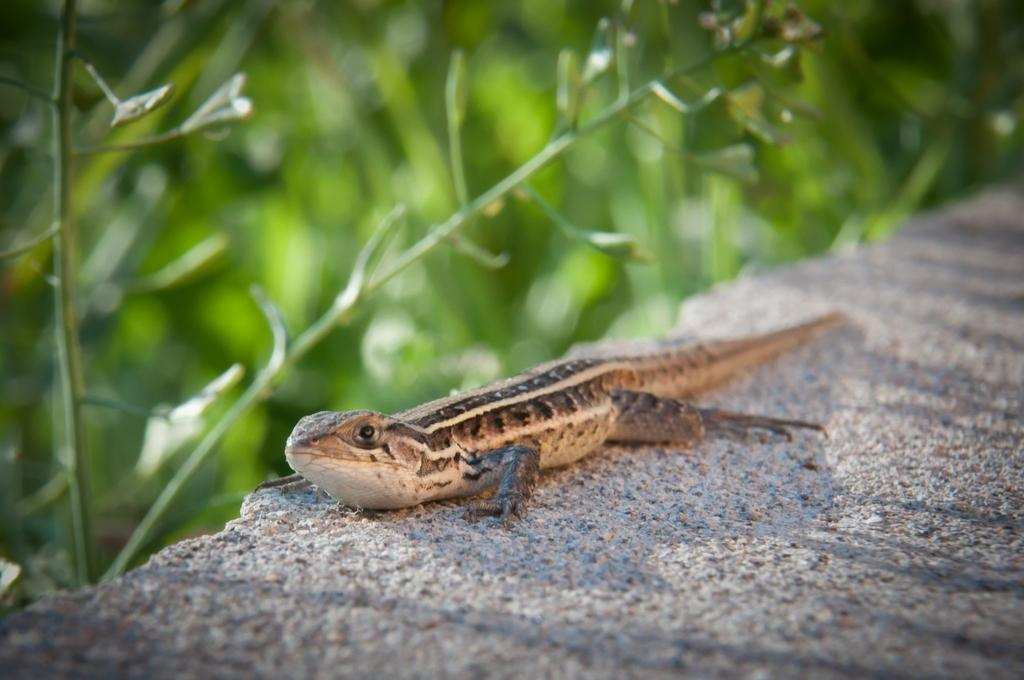What type of animal is in the image? There is a reptile in the image. Can you describe the background of the image? The background of the image is blurry. What type of stew is the farmer preparing in the image? There is no farmer or stew present in the image; it features a reptile and a blurry background. 